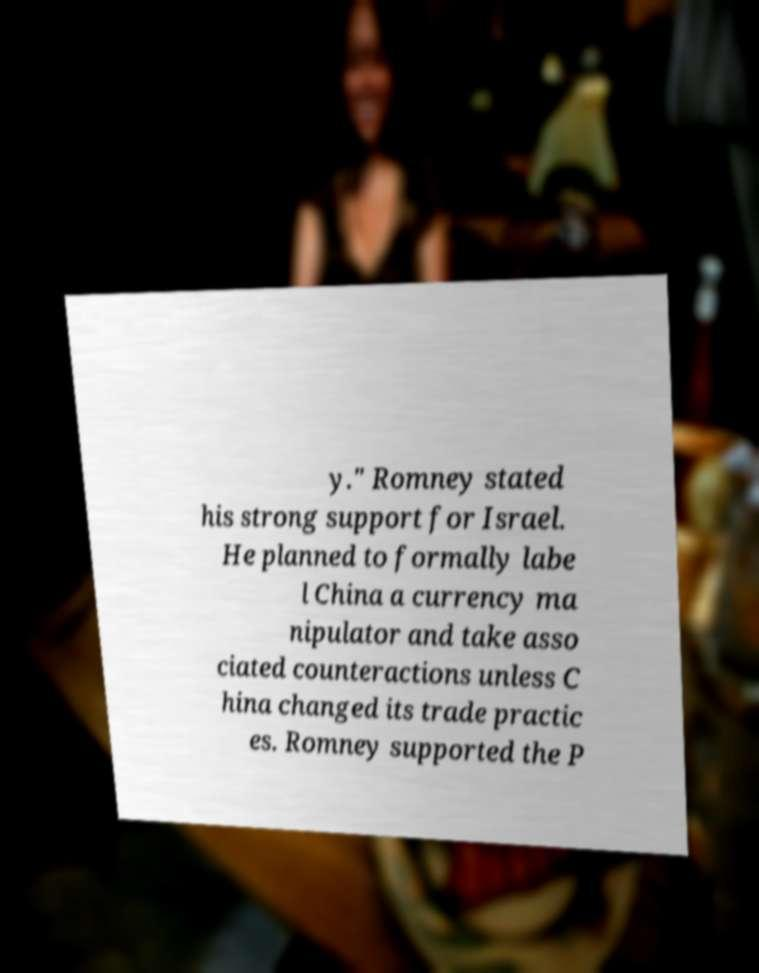There's text embedded in this image that I need extracted. Can you transcribe it verbatim? y." Romney stated his strong support for Israel. He planned to formally labe l China a currency ma nipulator and take asso ciated counteractions unless C hina changed its trade practic es. Romney supported the P 